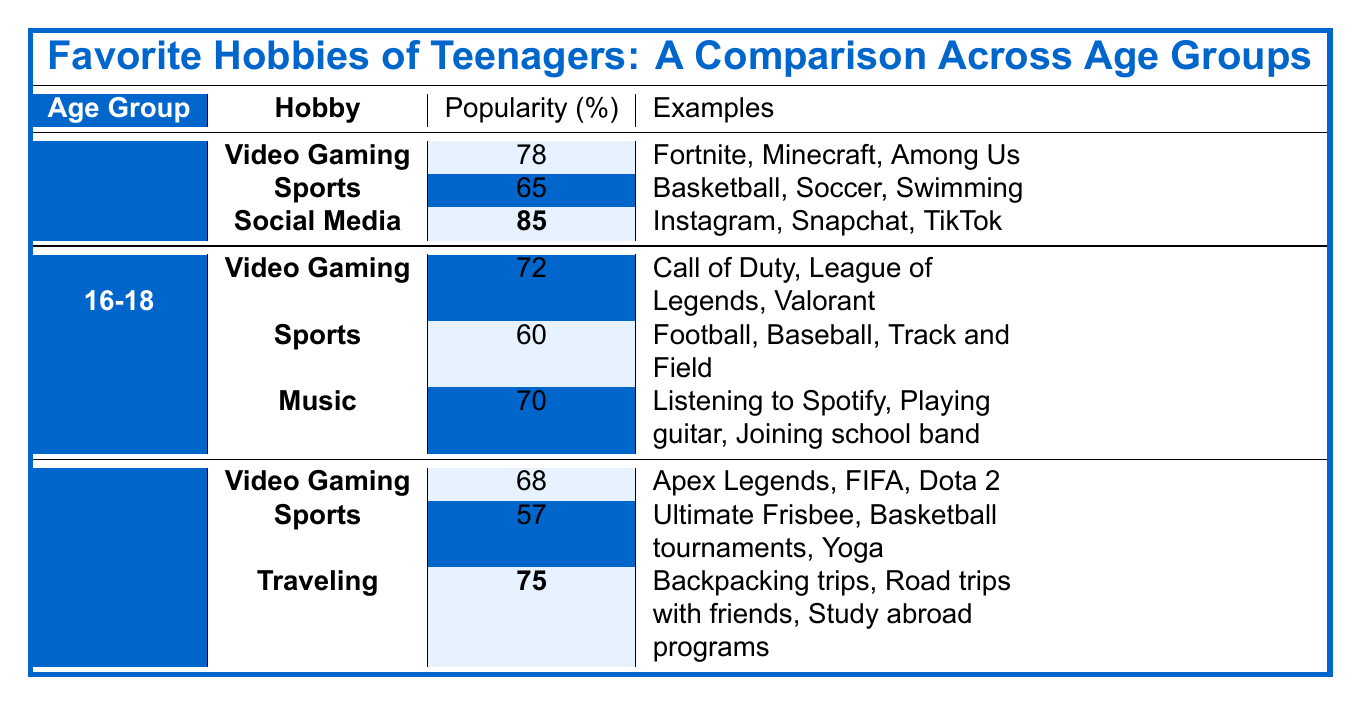What is the most popular hobby among teenagers aged 13-15? According to the table, the most popular hobby for the 13-15 age group is Social Media, with a popularity percentage of 85.
Answer: Social Media Which age group has the highest popularity percentage for Sports? By comparing the popularity percentages for Sports across the age groups, the 13-15 age group has the highest percentage at 65%.
Answer: 13-15 What is the average popularity percentage of Video Gaming across all age groups? To find the average, we calculate the percentages: (78 + 72 + 68) / 3 = 218 / 3 = 72.67.
Answer: 72.67 Is Music a hobby for teenagers in the 19-20 age group? The table shows that Music is not listed as a hobby for the 19-20 age group, so the answer is no.
Answer: No What is the difference in popularity percentage for Traveling between the 19-20 age group and the 16-18 age group? Traveling is only mentioned for the 19-20 age group with 75%. The 16-18 age group does not have Traveling listed, so we consider its percentage as 0. The difference is 75 - 0 = 75.
Answer: 75 Which hobby has the lowest popularity percentage among teenagers aged 19-20? The lowest percentage for the 19-20 age group is Sports, with a popularity percentage of 57.
Answer: Sports What percentage of teenagers aged 16-18 participate in Sports compared to Video Gaming? The percentage for Sports among 16-18 teenagers is 60%, while for Video Gaming, it is 72%. The comparison shows 72 - 60 = 12.
Answer: 12 Which hobby is more popular among 13-15-year-olds: Sports or Video Gaming? Comparing the two, Video Gaming has a popularity percentage of 78%, while Sports has 65%. Therefore, Video Gaming is more popular.
Answer: Video Gaming What is the total popularity percentage for the hobbies listed under the 13-15 age group? The total is calculated by adding the percentages: 78 (Video Gaming) + 65 (Sports) + 85 (Social Media) = 228.
Answer: 228 